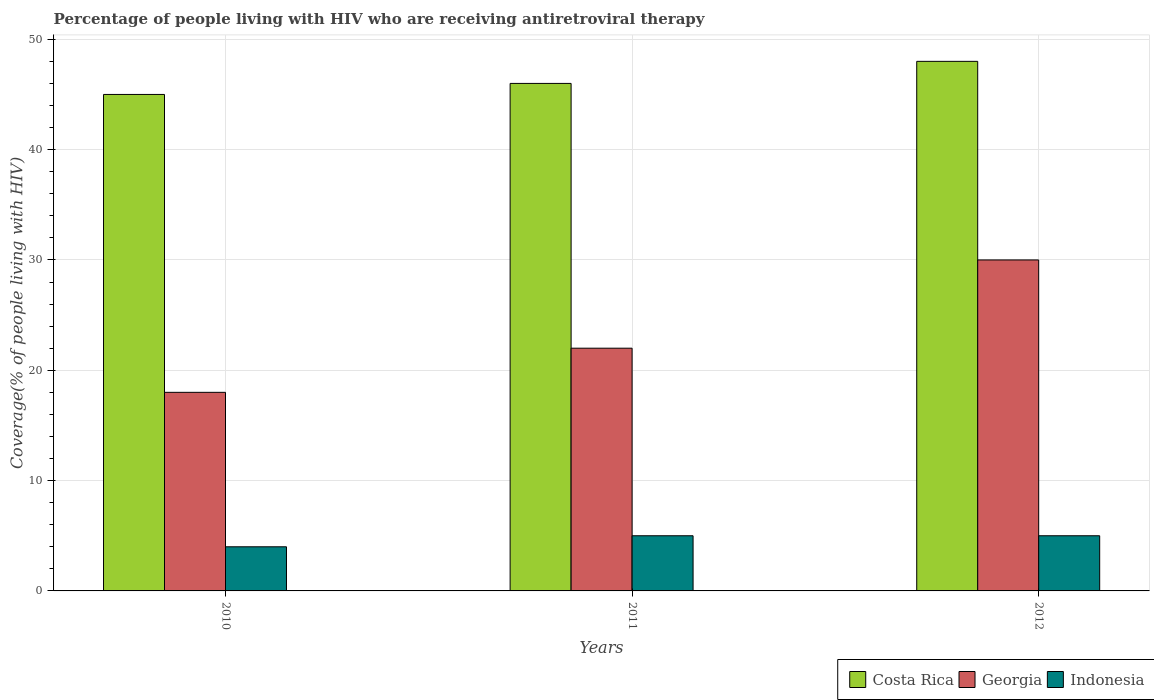Are the number of bars per tick equal to the number of legend labels?
Your answer should be compact. Yes. Are the number of bars on each tick of the X-axis equal?
Your response must be concise. Yes. How many bars are there on the 2nd tick from the right?
Provide a short and direct response. 3. What is the percentage of the HIV infected people who are receiving antiretroviral therapy in Georgia in 2011?
Keep it short and to the point. 22. Across all years, what is the maximum percentage of the HIV infected people who are receiving antiretroviral therapy in Indonesia?
Your response must be concise. 5. Across all years, what is the minimum percentage of the HIV infected people who are receiving antiretroviral therapy in Indonesia?
Give a very brief answer. 4. In which year was the percentage of the HIV infected people who are receiving antiretroviral therapy in Georgia minimum?
Offer a terse response. 2010. What is the total percentage of the HIV infected people who are receiving antiretroviral therapy in Costa Rica in the graph?
Offer a very short reply. 139. What is the difference between the percentage of the HIV infected people who are receiving antiretroviral therapy in Costa Rica in 2011 and that in 2012?
Keep it short and to the point. -2. What is the difference between the percentage of the HIV infected people who are receiving antiretroviral therapy in Indonesia in 2011 and the percentage of the HIV infected people who are receiving antiretroviral therapy in Costa Rica in 2012?
Make the answer very short. -43. What is the average percentage of the HIV infected people who are receiving antiretroviral therapy in Georgia per year?
Make the answer very short. 23.33. In the year 2011, what is the difference between the percentage of the HIV infected people who are receiving antiretroviral therapy in Georgia and percentage of the HIV infected people who are receiving antiretroviral therapy in Costa Rica?
Your answer should be compact. -24. In how many years, is the percentage of the HIV infected people who are receiving antiretroviral therapy in Georgia greater than 12 %?
Ensure brevity in your answer.  3. Is the percentage of the HIV infected people who are receiving antiretroviral therapy in Georgia in 2010 less than that in 2012?
Make the answer very short. Yes. What is the difference between the highest and the second highest percentage of the HIV infected people who are receiving antiretroviral therapy in Georgia?
Offer a terse response. 8. What is the difference between the highest and the lowest percentage of the HIV infected people who are receiving antiretroviral therapy in Indonesia?
Provide a short and direct response. 1. Is the sum of the percentage of the HIV infected people who are receiving antiretroviral therapy in Indonesia in 2010 and 2011 greater than the maximum percentage of the HIV infected people who are receiving antiretroviral therapy in Georgia across all years?
Provide a succinct answer. No. What does the 1st bar from the right in 2012 represents?
Keep it short and to the point. Indonesia. How many bars are there?
Offer a very short reply. 9. Are all the bars in the graph horizontal?
Offer a terse response. No. How many years are there in the graph?
Keep it short and to the point. 3. Where does the legend appear in the graph?
Provide a short and direct response. Bottom right. How many legend labels are there?
Provide a short and direct response. 3. What is the title of the graph?
Ensure brevity in your answer.  Percentage of people living with HIV who are receiving antiretroviral therapy. Does "Central African Republic" appear as one of the legend labels in the graph?
Ensure brevity in your answer.  No. What is the label or title of the Y-axis?
Keep it short and to the point. Coverage(% of people living with HIV). What is the Coverage(% of people living with HIV) in Costa Rica in 2010?
Your answer should be very brief. 45. What is the Coverage(% of people living with HIV) in Georgia in 2010?
Make the answer very short. 18. What is the Coverage(% of people living with HIV) in Indonesia in 2010?
Make the answer very short. 4. What is the Coverage(% of people living with HIV) of Georgia in 2011?
Keep it short and to the point. 22. Across all years, what is the maximum Coverage(% of people living with HIV) of Costa Rica?
Make the answer very short. 48. Across all years, what is the minimum Coverage(% of people living with HIV) of Costa Rica?
Keep it short and to the point. 45. Across all years, what is the minimum Coverage(% of people living with HIV) in Georgia?
Keep it short and to the point. 18. What is the total Coverage(% of people living with HIV) of Costa Rica in the graph?
Your answer should be compact. 139. What is the total Coverage(% of people living with HIV) of Indonesia in the graph?
Ensure brevity in your answer.  14. What is the difference between the Coverage(% of people living with HIV) in Costa Rica in 2010 and that in 2012?
Keep it short and to the point. -3. What is the difference between the Coverage(% of people living with HIV) in Georgia in 2010 and that in 2012?
Give a very brief answer. -12. What is the difference between the Coverage(% of people living with HIV) of Costa Rica in 2011 and that in 2012?
Your answer should be compact. -2. What is the difference between the Coverage(% of people living with HIV) of Georgia in 2011 and that in 2012?
Provide a succinct answer. -8. What is the difference between the Coverage(% of people living with HIV) of Costa Rica in 2010 and the Coverage(% of people living with HIV) of Georgia in 2011?
Make the answer very short. 23. What is the difference between the Coverage(% of people living with HIV) in Costa Rica in 2010 and the Coverage(% of people living with HIV) in Indonesia in 2011?
Ensure brevity in your answer.  40. What is the difference between the Coverage(% of people living with HIV) of Georgia in 2010 and the Coverage(% of people living with HIV) of Indonesia in 2011?
Your answer should be very brief. 13. What is the difference between the Coverage(% of people living with HIV) of Costa Rica in 2010 and the Coverage(% of people living with HIV) of Georgia in 2012?
Make the answer very short. 15. What is the difference between the Coverage(% of people living with HIV) of Costa Rica in 2010 and the Coverage(% of people living with HIV) of Indonesia in 2012?
Your response must be concise. 40. What is the difference between the Coverage(% of people living with HIV) in Costa Rica in 2011 and the Coverage(% of people living with HIV) in Georgia in 2012?
Ensure brevity in your answer.  16. What is the difference between the Coverage(% of people living with HIV) in Georgia in 2011 and the Coverage(% of people living with HIV) in Indonesia in 2012?
Your answer should be compact. 17. What is the average Coverage(% of people living with HIV) of Costa Rica per year?
Give a very brief answer. 46.33. What is the average Coverage(% of people living with HIV) of Georgia per year?
Give a very brief answer. 23.33. What is the average Coverage(% of people living with HIV) in Indonesia per year?
Your answer should be compact. 4.67. In the year 2010, what is the difference between the Coverage(% of people living with HIV) in Costa Rica and Coverage(% of people living with HIV) in Georgia?
Offer a terse response. 27. In the year 2011, what is the difference between the Coverage(% of people living with HIV) of Costa Rica and Coverage(% of people living with HIV) of Indonesia?
Offer a very short reply. 41. In the year 2011, what is the difference between the Coverage(% of people living with HIV) in Georgia and Coverage(% of people living with HIV) in Indonesia?
Your answer should be compact. 17. In the year 2012, what is the difference between the Coverage(% of people living with HIV) of Georgia and Coverage(% of people living with HIV) of Indonesia?
Make the answer very short. 25. What is the ratio of the Coverage(% of people living with HIV) of Costa Rica in 2010 to that in 2011?
Your answer should be compact. 0.98. What is the ratio of the Coverage(% of people living with HIV) in Georgia in 2010 to that in 2011?
Your response must be concise. 0.82. What is the ratio of the Coverage(% of people living with HIV) of Costa Rica in 2010 to that in 2012?
Your response must be concise. 0.94. What is the ratio of the Coverage(% of people living with HIV) of Indonesia in 2010 to that in 2012?
Provide a succinct answer. 0.8. What is the ratio of the Coverage(% of people living with HIV) of Georgia in 2011 to that in 2012?
Your answer should be compact. 0.73. What is the difference between the highest and the second highest Coverage(% of people living with HIV) of Georgia?
Ensure brevity in your answer.  8. What is the difference between the highest and the second highest Coverage(% of people living with HIV) in Indonesia?
Your answer should be very brief. 0. 